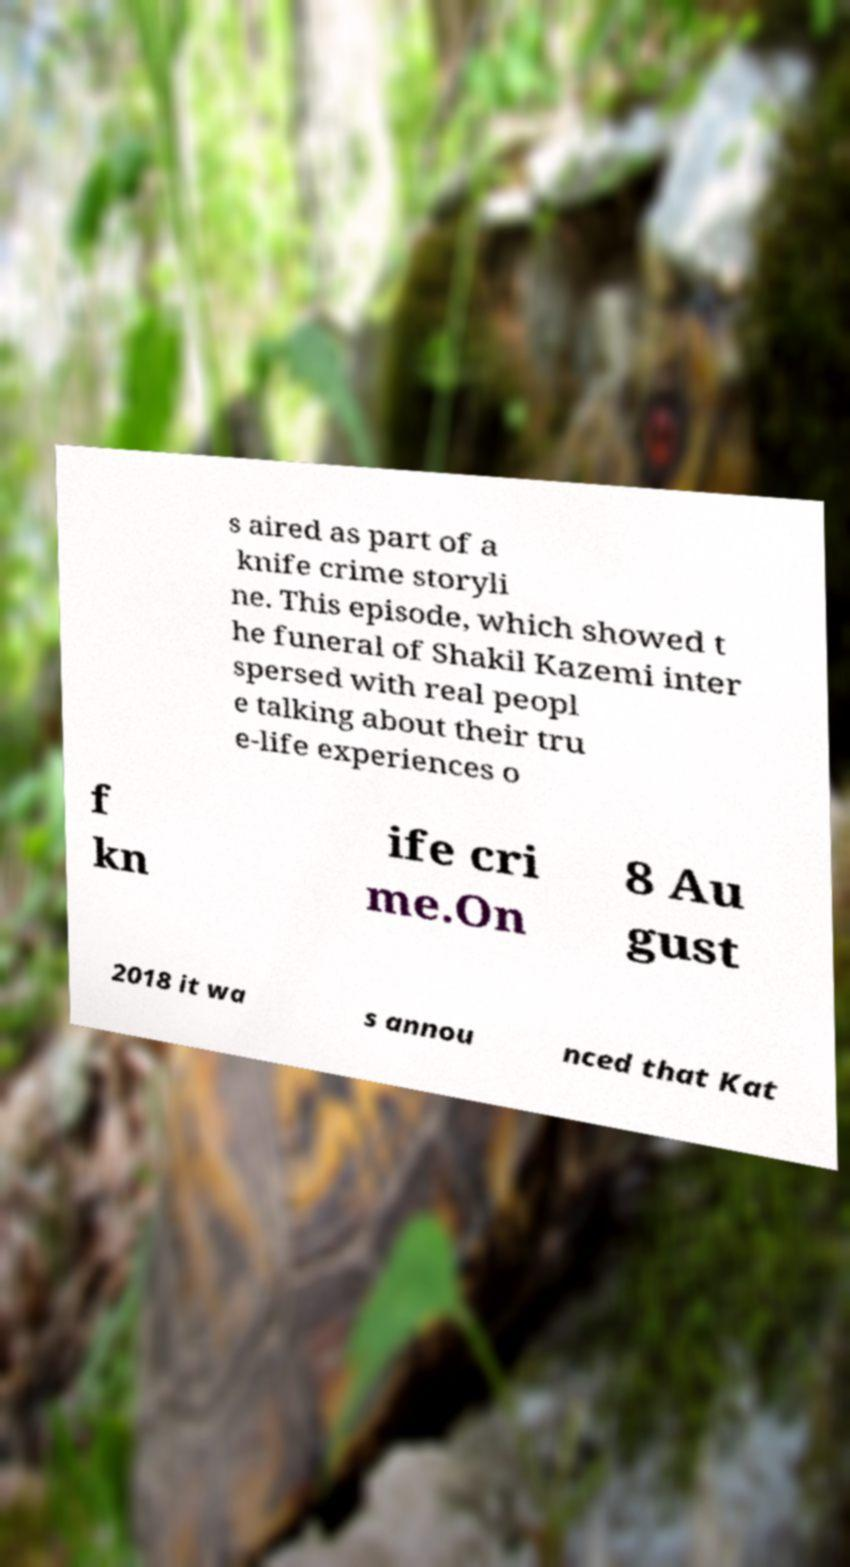For documentation purposes, I need the text within this image transcribed. Could you provide that? s aired as part of a knife crime storyli ne. This episode, which showed t he funeral of Shakil Kazemi inter spersed with real peopl e talking about their tru e-life experiences o f kn ife cri me.On 8 Au gust 2018 it wa s annou nced that Kat 